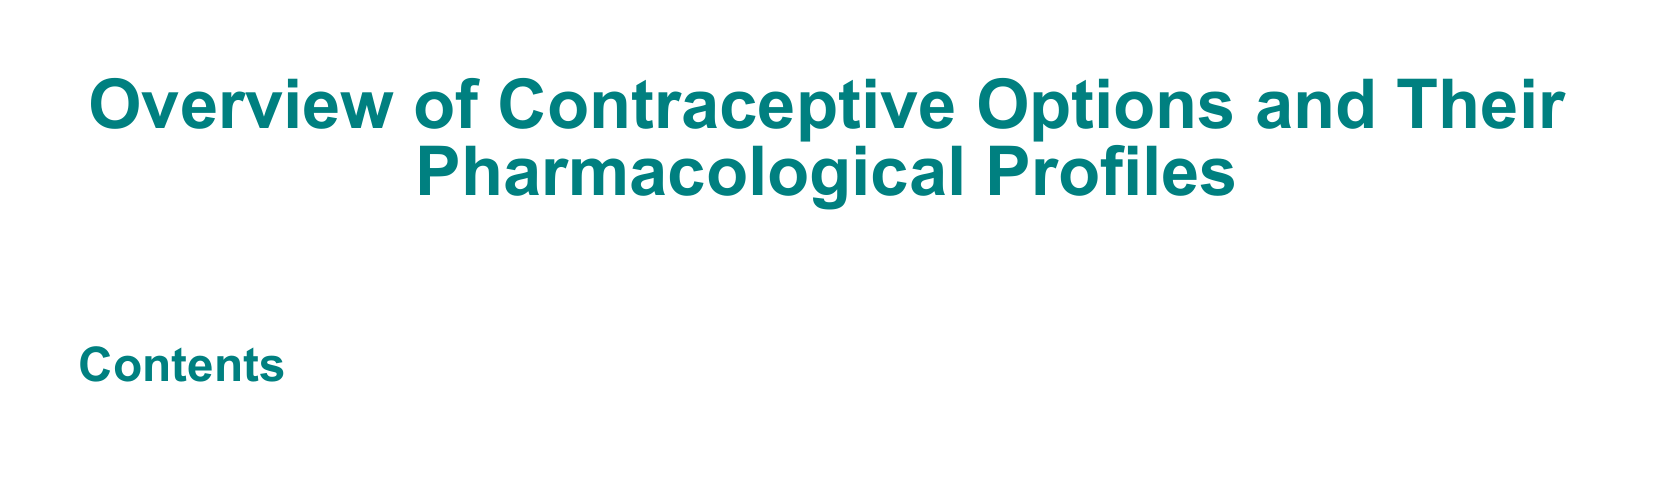What is the title of the document? The title is presented at the beginning of the document, which states the overall subject matter.
Answer: Overview of Contraceptive Options and Their Pharmacological Profiles How many sections are in the table of contents? The total number of sections can be determined by counting the listed items in the table of contents.
Answer: 0 What color is used for section titles? The color used for section titles is specified within the code for visual purposes.
Answer: Teal What is the intended font for the document? The document specifies a particular font to use throughout the text, indicating its visual style.
Answer: Arial What does the document outline? The document's title provides a clear indication of the overarching theme or focus of the content.
Answer: Contraceptive Options and Their Pharmacological Profiles What design element is used for subsection titles? The specific design element for subsection titles is mentioned in the code for clarity and visual separation.
Answer: Teal with an 80% shade 